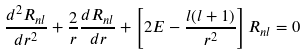Convert formula to latex. <formula><loc_0><loc_0><loc_500><loc_500>\frac { d ^ { 2 } R _ { n l } } { d r ^ { 2 } } + \frac { 2 } { r } \frac { d R _ { n l } } { d r } + \left [ 2 E - \frac { l ( l + 1 ) } { r ^ { 2 } } \right ] R _ { n l } = 0</formula> 